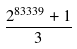Convert formula to latex. <formula><loc_0><loc_0><loc_500><loc_500>\frac { 2 ^ { 8 3 3 3 9 } + 1 } { 3 }</formula> 